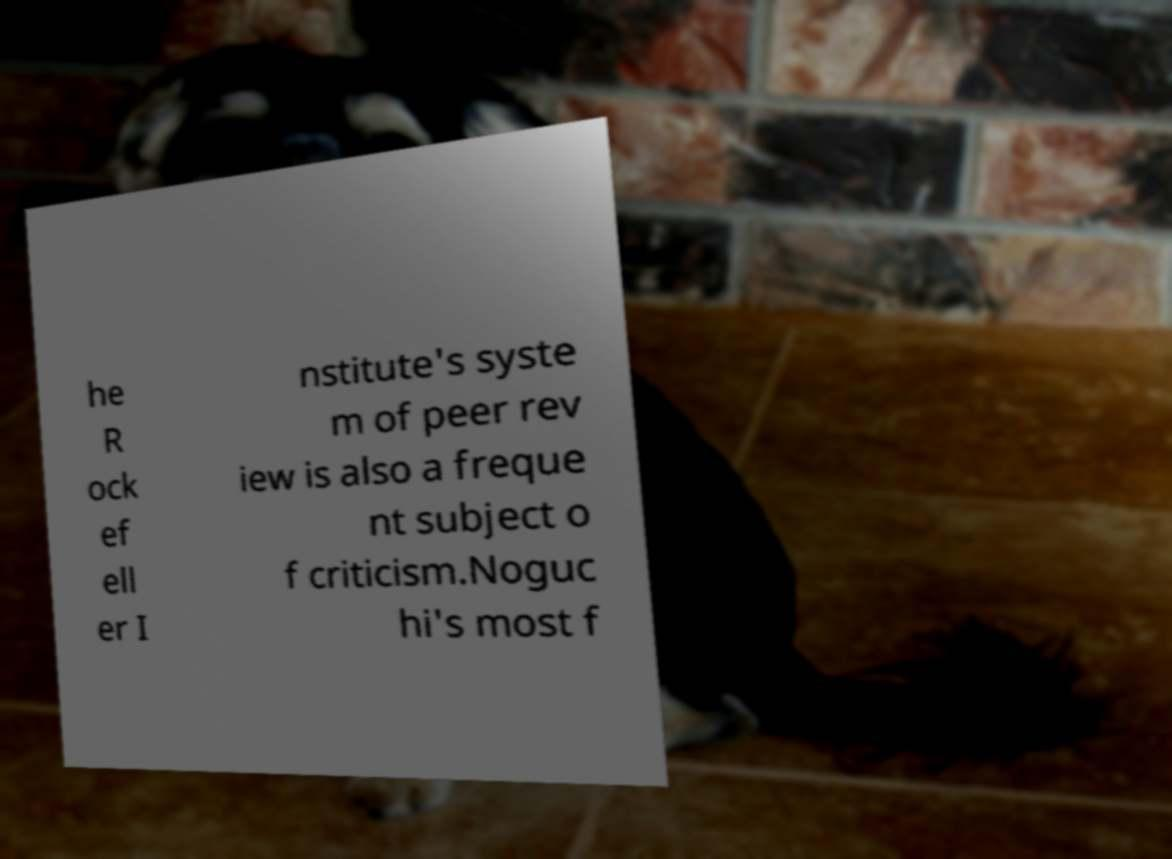Could you extract and type out the text from this image? he R ock ef ell er I nstitute's syste m of peer rev iew is also a freque nt subject o f criticism.Noguc hi's most f 